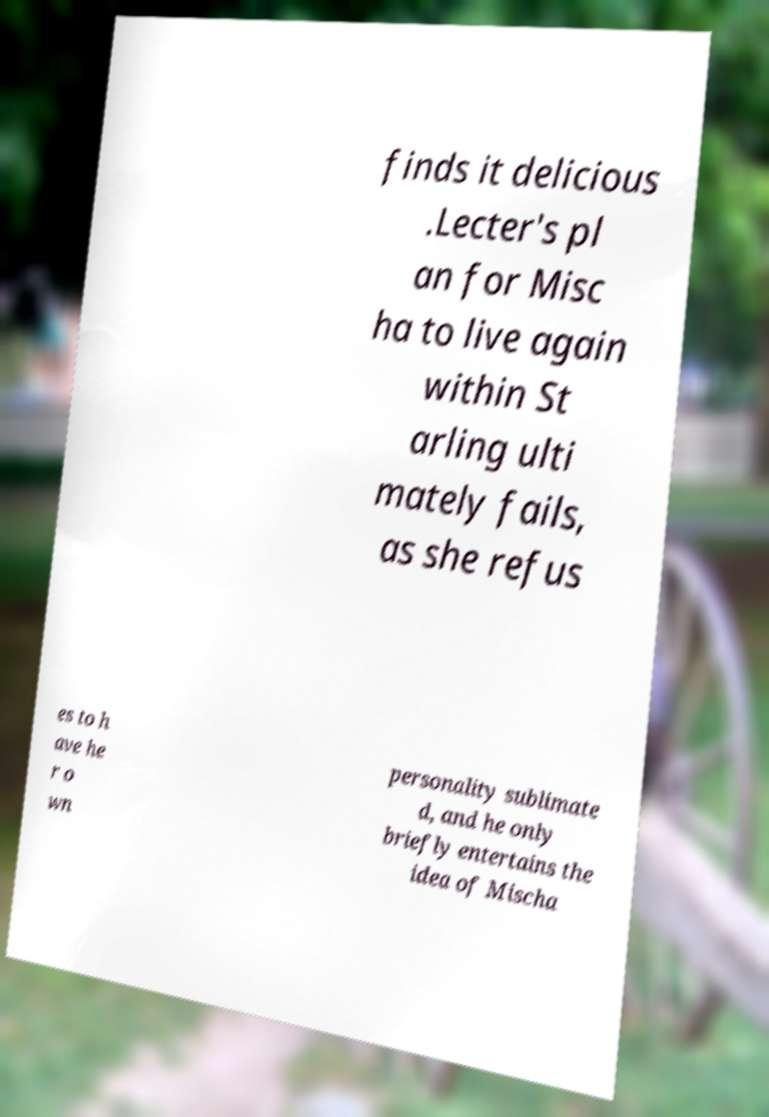Please read and relay the text visible in this image. What does it say? finds it delicious .Lecter's pl an for Misc ha to live again within St arling ulti mately fails, as she refus es to h ave he r o wn personality sublimate d, and he only briefly entertains the idea of Mischa 